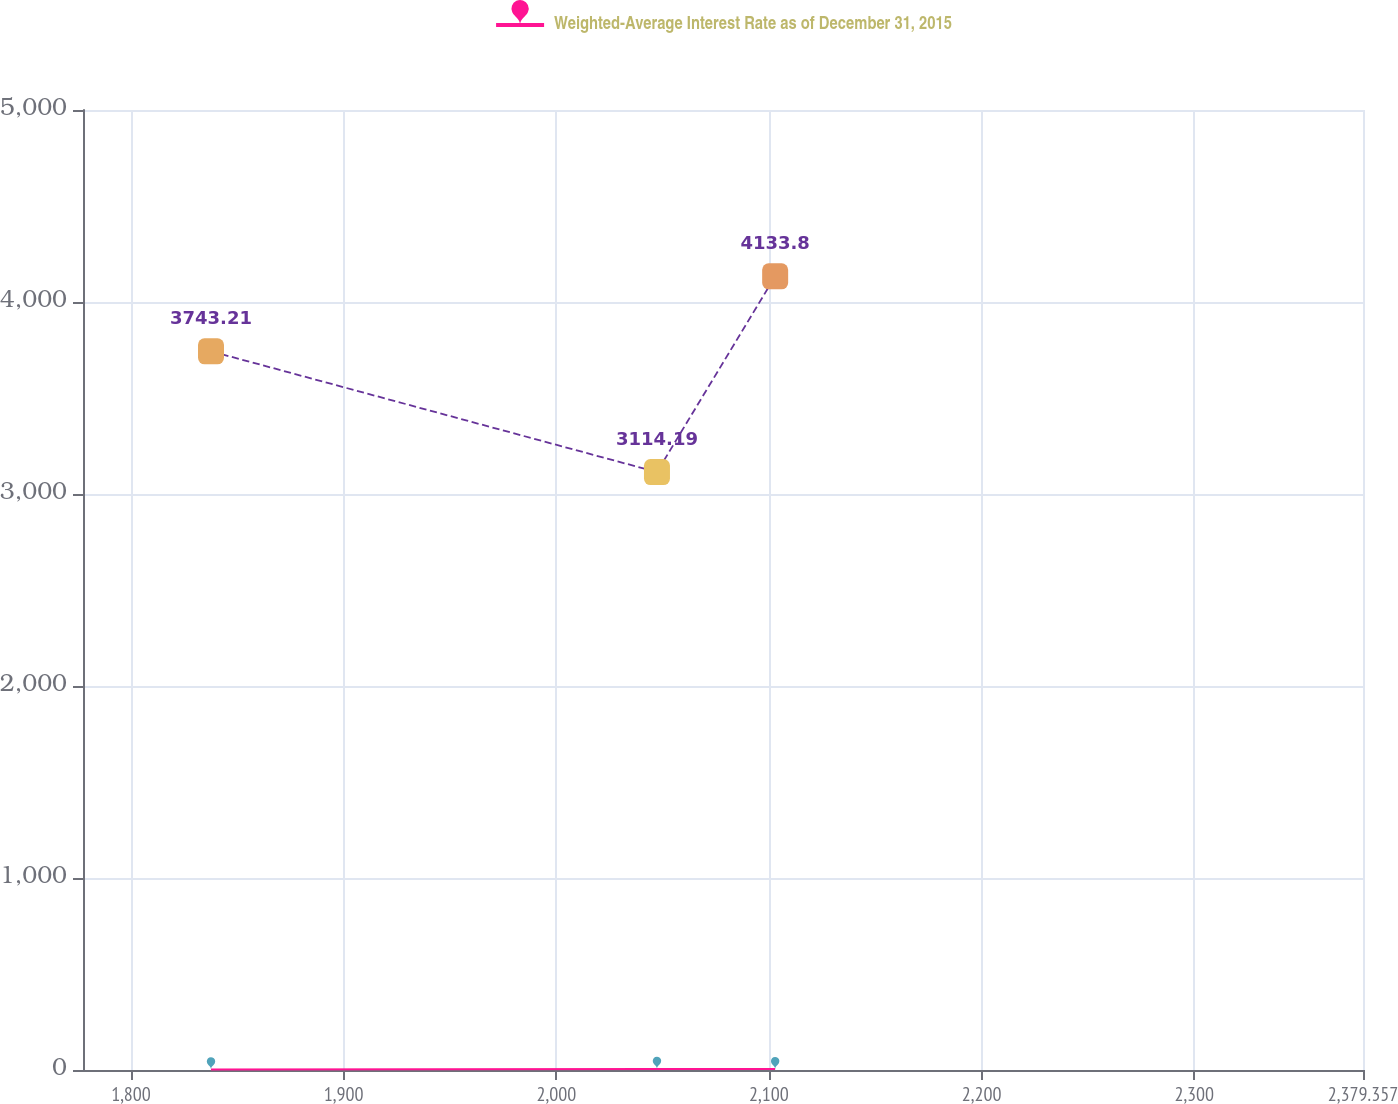Convert chart to OTSL. <chart><loc_0><loc_0><loc_500><loc_500><line_chart><ecel><fcel>Weighted-Average Interest Rate as of December 31, 2015<fcel>Unnamed: 2<nl><fcel>1837.62<fcel>3.12<fcel>3743.21<nl><fcel>2047.34<fcel>5.83<fcel>3114.19<nl><fcel>2102.92<fcel>4.71<fcel>4133.8<nl><fcel>2383.97<fcel>2.62<fcel>2075.41<nl><fcel>2439.55<fcel>3.44<fcel>5981.34<nl></chart> 